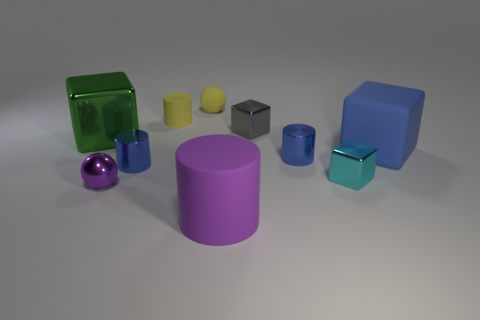Subtract all purple cylinders. How many cylinders are left? 3 Subtract all metal blocks. How many blocks are left? 1 Subtract 1 cylinders. How many cylinders are left? 3 Subtract all gray cubes. Subtract all cyan balls. How many cubes are left? 3 Subtract all purple cubes. How many brown balls are left? 0 Subtract all large green metal cubes. Subtract all purple metallic things. How many objects are left? 8 Add 2 matte things. How many matte things are left? 6 Add 6 small shiny blocks. How many small shiny blocks exist? 8 Subtract 0 gray cylinders. How many objects are left? 10 Subtract all spheres. How many objects are left? 8 